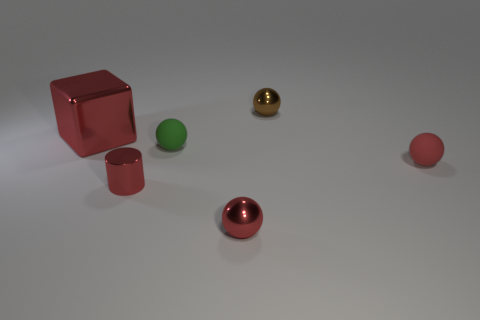Subtract 1 spheres. How many spheres are left? 3 Add 3 green objects. How many objects exist? 9 Subtract all spheres. How many objects are left? 2 Add 1 tiny red metallic things. How many tiny red metallic things are left? 3 Add 1 small brown rubber balls. How many small brown rubber balls exist? 1 Subtract 0 blue cylinders. How many objects are left? 6 Subtract all small matte balls. Subtract all large red blocks. How many objects are left? 3 